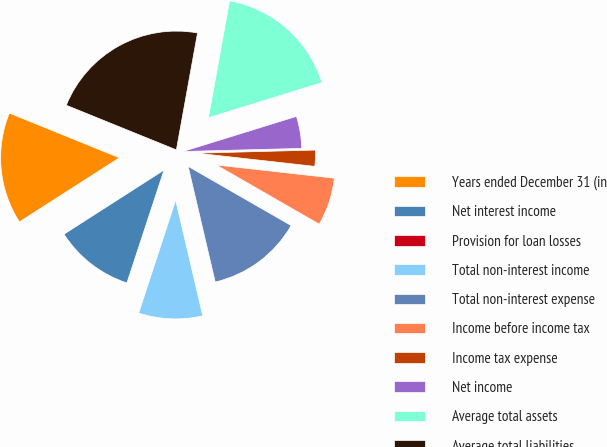Convert chart. <chart><loc_0><loc_0><loc_500><loc_500><pie_chart><fcel>Years ended December 31 (in<fcel>Net interest income<fcel>Provision for loan losses<fcel>Total non-interest income<fcel>Total non-interest expense<fcel>Income before income tax<fcel>Income tax expense<fcel>Net income<fcel>Average total assets<fcel>Average total liabilities<nl><fcel>15.21%<fcel>10.87%<fcel>0.02%<fcel>8.7%<fcel>13.04%<fcel>6.53%<fcel>2.19%<fcel>4.36%<fcel>17.38%<fcel>21.72%<nl></chart> 